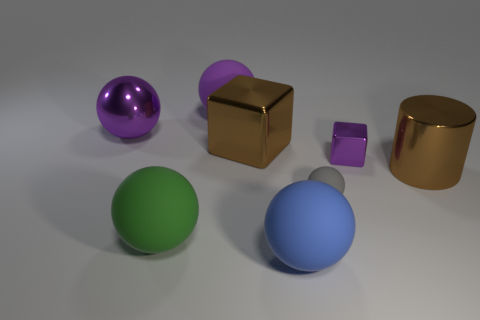How many big green rubber things are the same shape as the blue thing?
Make the answer very short. 1. There is a large brown object that is in front of the brown metallic thing that is behind the brown metal cylinder; what is it made of?
Offer a very short reply. Metal. How big is the purple object that is in front of the big cube?
Ensure brevity in your answer.  Small. How many brown things are either big metallic objects or big shiny blocks?
Make the answer very short. 2. Are there any other things that are made of the same material as the large brown cylinder?
Give a very brief answer. Yes. What is the material of the big green object that is the same shape as the blue rubber object?
Offer a very short reply. Rubber. Is the number of large brown metal things that are in front of the blue ball the same as the number of gray rubber objects?
Ensure brevity in your answer.  No. There is a thing that is both on the right side of the small matte object and behind the brown cylinder; what is its size?
Offer a very short reply. Small. Are there any other things that have the same color as the tiny metallic block?
Offer a terse response. Yes. There is a brown thing to the left of the large brown object that is in front of the small metal block; what size is it?
Your response must be concise. Large. 